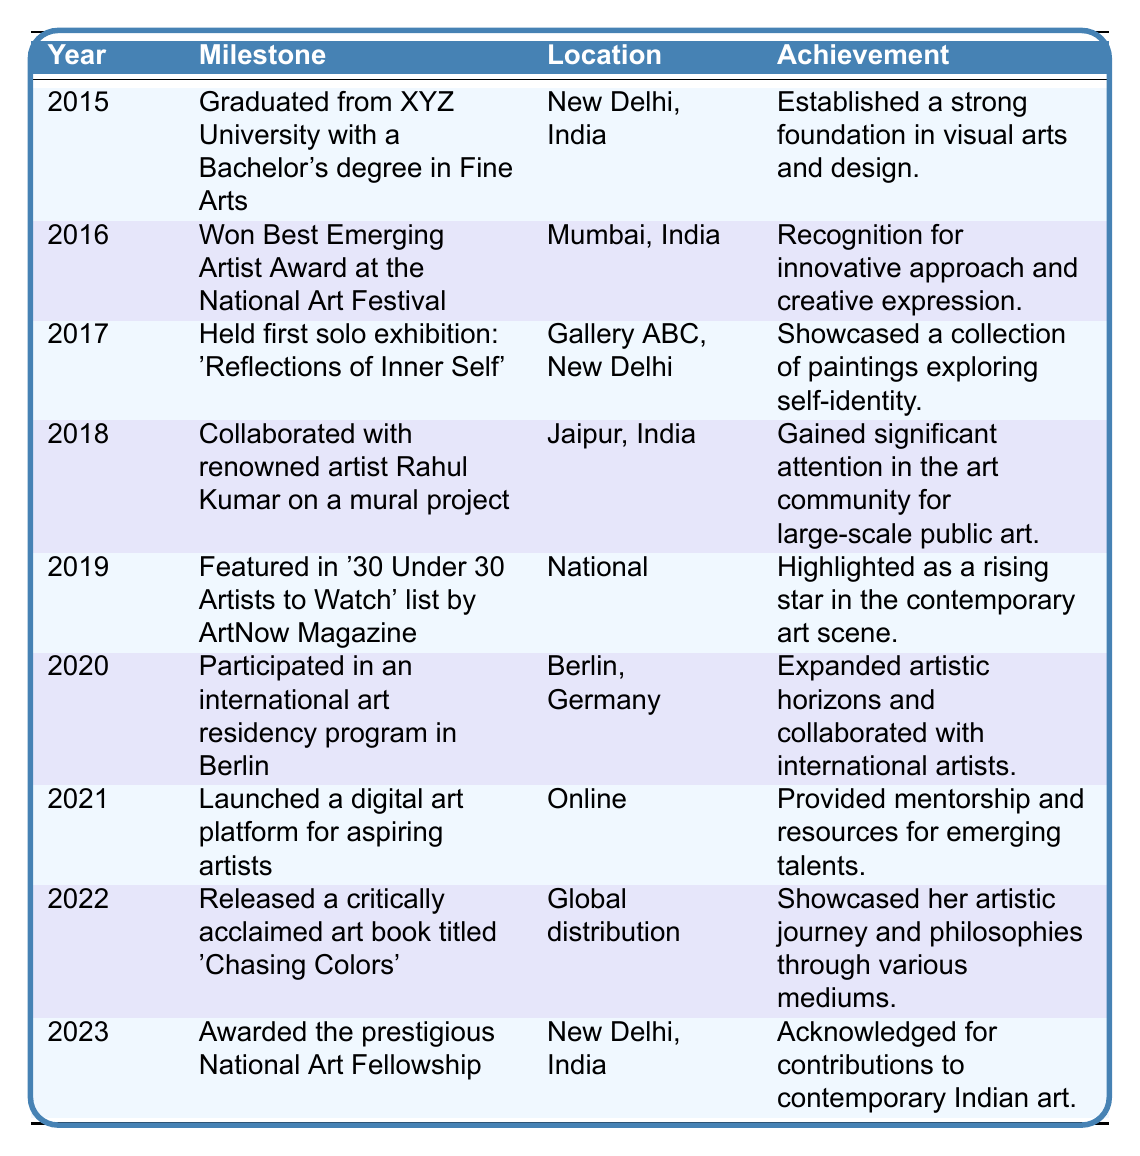What year did Mreenal Deshraj graduate from university? The table indicates that Mreenal graduated in the year 2015.
Answer: 2015 What was Mreenal Deshraj's first solo exhibition and where was it held? The first solo exhibition was titled 'Reflections of Inner Self' and it was held at Gallery ABC in New Delhi in 2017.
Answer: 'Reflections of Inner Self', Gallery ABC, New Delhi How many years did it take for Mreenal to win the Best Emerging Artist Award after graduating? Mreenal graduated in 2015 and won the award in 2016, which is a difference of 1 year.
Answer: 1 year In which year did Mreenal collaborate with Rahul Kumar and what was the type of project? The collaboration with Rahul Kumar occurred in 2018 on a mural project.
Answer: 2018, mural project What was the location of the international art residency program that Mreenal participated in? According to the table, the residency program took place in Berlin, Germany.
Answer: Berlin, Germany How many milestones are listed in the table? The table shows a total of 9 milestones, one for each year from 2015 to 2023.
Answer: 9 milestones What significant recognition did Mreenal receive in 2019? In 2019, she was featured in the '30 Under 30 Artists to Watch' list by ArtNow Magazine.
Answer: Featured in '30 Under 30 Artists to Watch' Did Mreenal Deshraj receive any awards in 2022? No, the milestone listed in 2022 is about the release of her art book, not an award.
Answer: No What was the nature of the achievement associated with the National Art Fellowship in 2023? The achievement was recognition for her contributions to contemporary Indian art.
Answer: Acknowledged for contributions to contemporary Indian art Based on the table, what percentage of milestones involved publications (art book release)? There is 1 publication milestone out of 9 total milestones, which is (1/9)*100 = 11.11%.
Answer: 11.11% Which year saw the establishment of Mreenal's digital art platform? The digital art platform was launched in 2021, according to the table.
Answer: 2021 